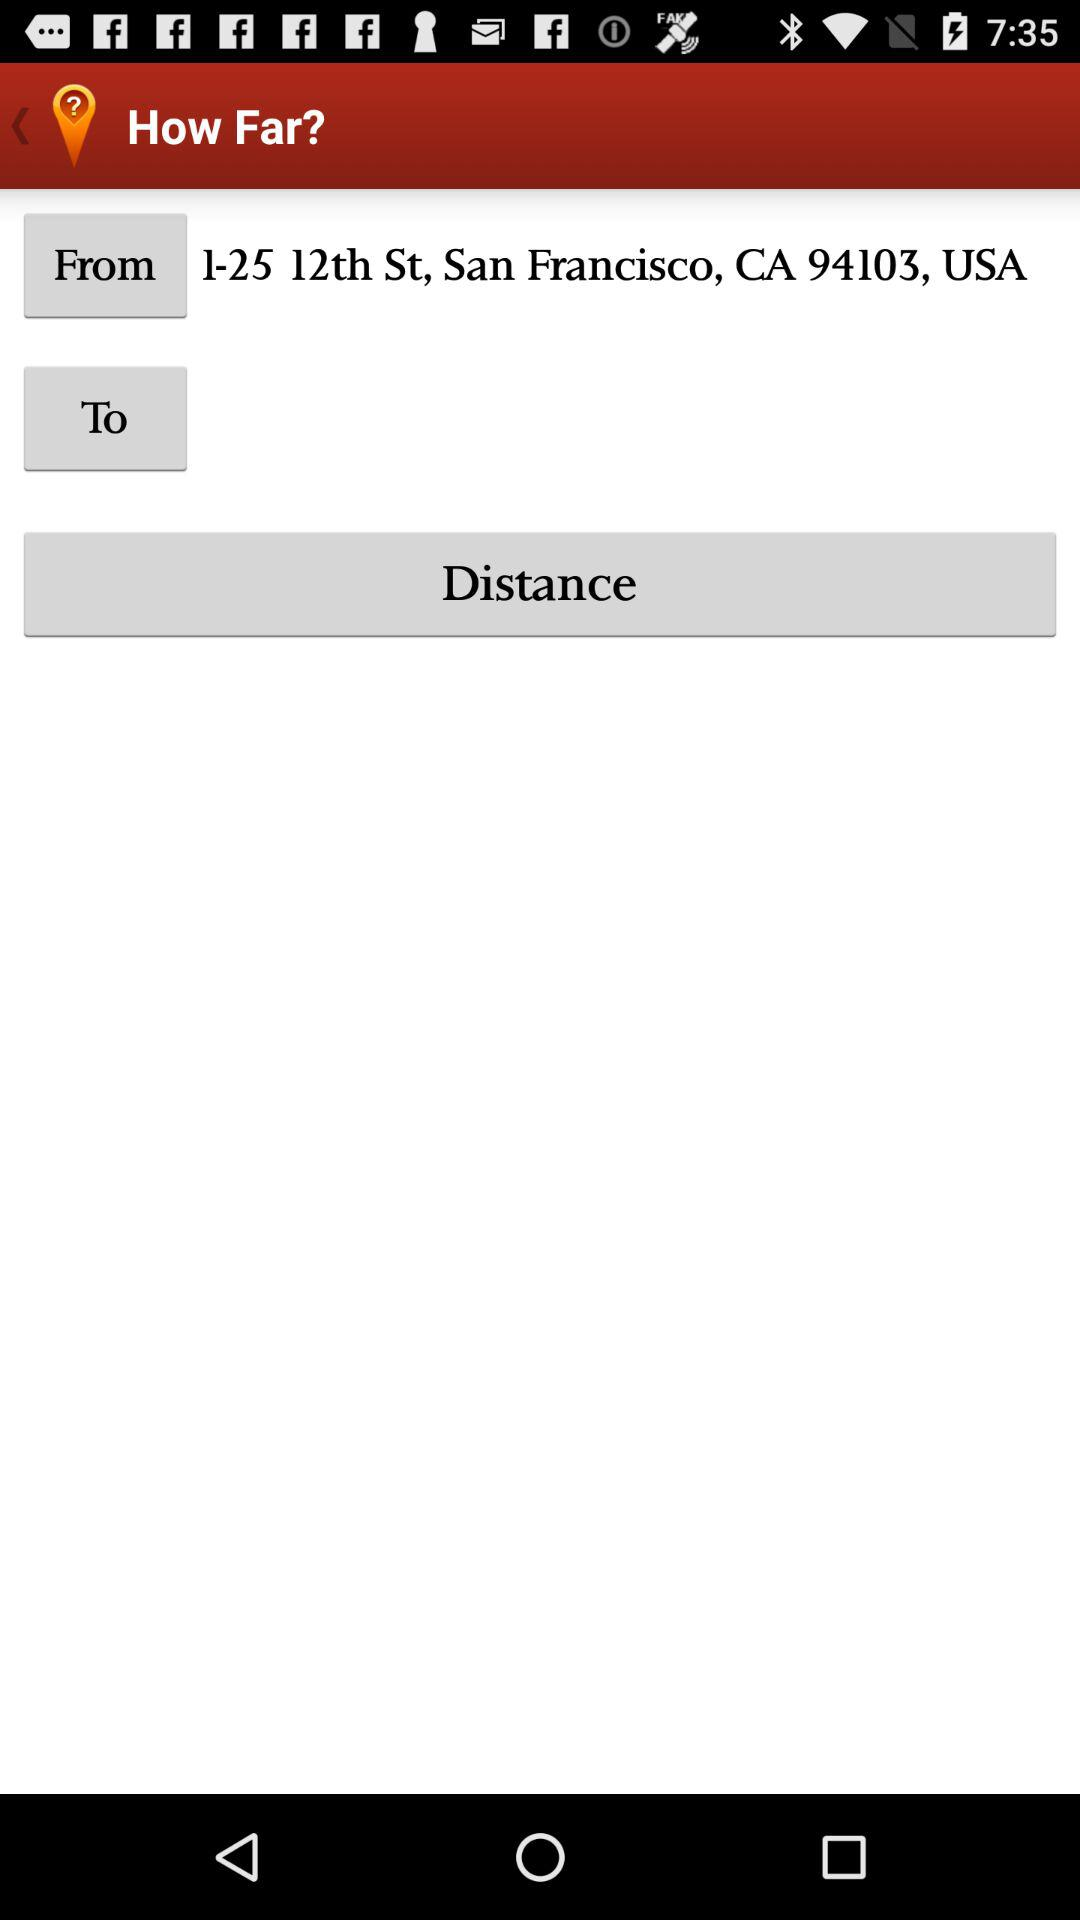What is the name of the application? The name of the application is "How Far?". 